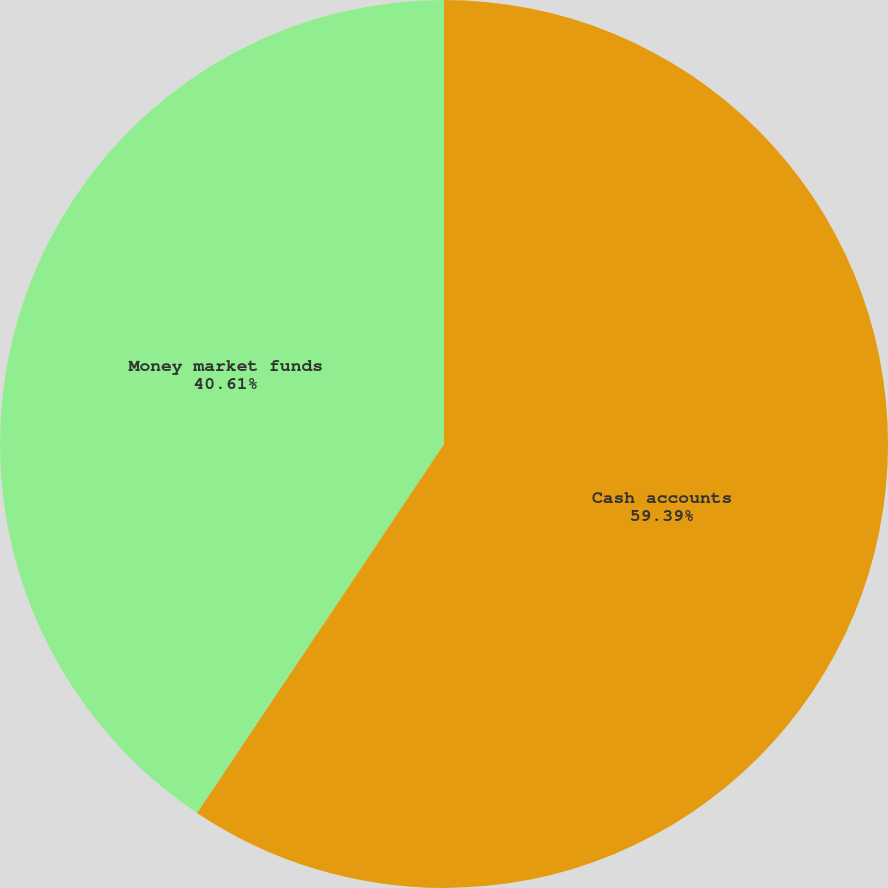Convert chart. <chart><loc_0><loc_0><loc_500><loc_500><pie_chart><fcel>Cash accounts<fcel>Money market funds<nl><fcel>59.39%<fcel>40.61%<nl></chart> 